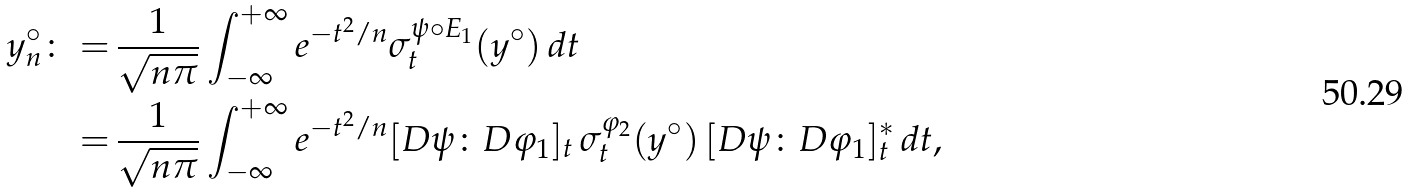Convert formula to latex. <formula><loc_0><loc_0><loc_500><loc_500>y _ { n } ^ { \circ } \colon = & \, \frac { 1 } { \sqrt { n \pi } } \int _ { - \infty } ^ { + \infty } e ^ { - t ^ { 2 } / n } \sigma _ { t } ^ { \psi \circ E _ { 1 } } ( y ^ { \circ } ) \, d t \\ = & \, \frac { 1 } { \sqrt { n \pi } } \int _ { - \infty } ^ { + \infty } e ^ { - t ^ { 2 } / n } [ D \psi \colon D \varphi _ { 1 } ] _ { t } \, \sigma _ { t } ^ { \varphi _ { 2 } } ( y ^ { \circ } ) \, [ D \psi \colon D \varphi _ { 1 } ] _ { t } ^ { * } \, d t ,</formula> 